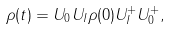Convert formula to latex. <formula><loc_0><loc_0><loc_500><loc_500>\rho ( t ) = U _ { 0 } U _ { I } \rho ( 0 ) U _ { I } ^ { + } U _ { 0 } ^ { + } ,</formula> 